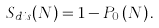<formula> <loc_0><loc_0><loc_500><loc_500>S _ { d i s } ( N ) = 1 - P _ { 0 } \left ( N \right ) .</formula> 